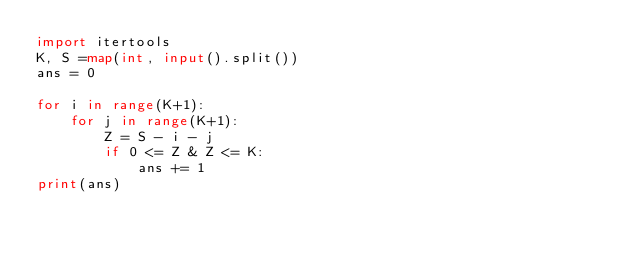<code> <loc_0><loc_0><loc_500><loc_500><_Python_>import itertools
K, S =map(int, input().split())
ans = 0

for i in range(K+1):
    for j in range(K+1):
        Z = S - i - j
        if 0 <= Z & Z <= K:
            ans += 1
print(ans)</code> 